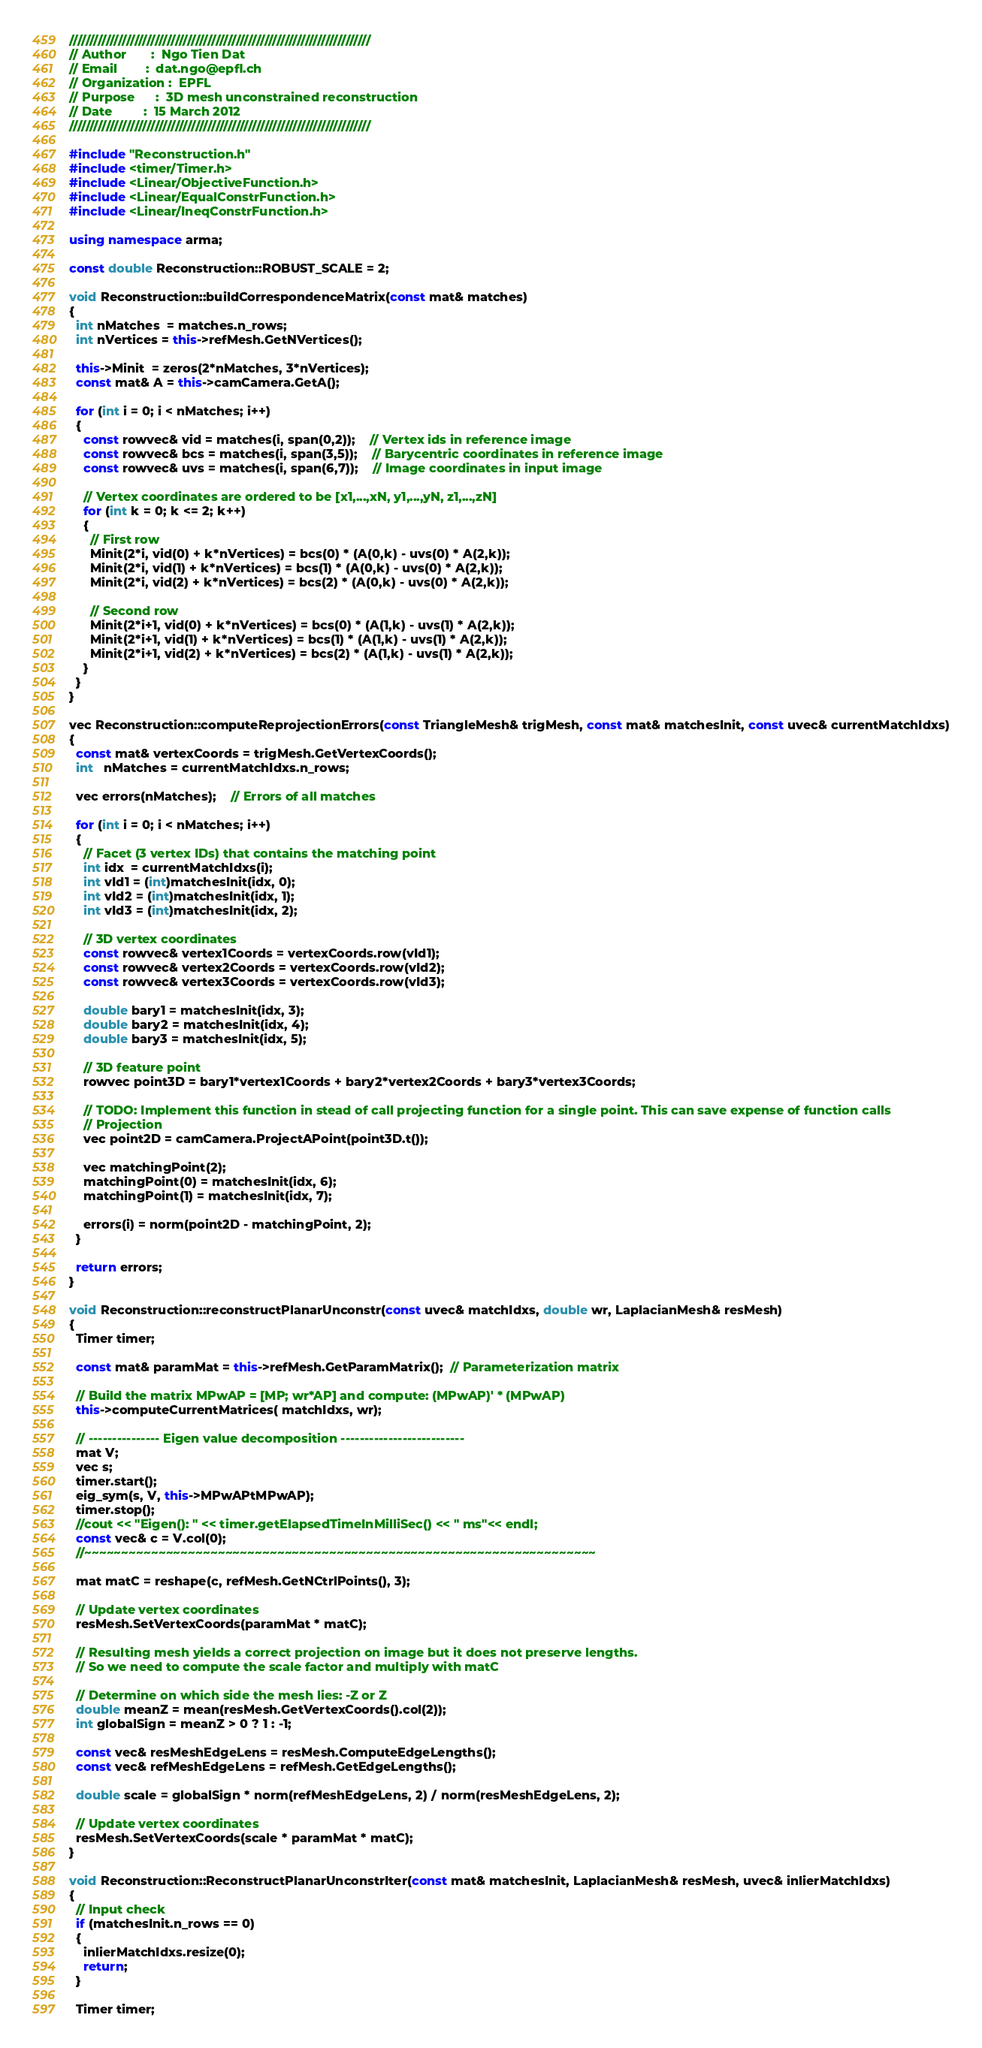<code> <loc_0><loc_0><loc_500><loc_500><_C++_>//////////////////////////////////////////////////////////////////////////
// Author       :  Ngo Tien Dat
// Email        :  dat.ngo@epfl.ch
// Organization :  EPFL
// Purpose      :  3D mesh unconstrained reconstruction
// Date         :  15 March 2012
//////////////////////////////////////////////////////////////////////////

#include "Reconstruction.h"
#include <timer/Timer.h>
#include <Linear/ObjectiveFunction.h>
#include <Linear/EqualConstrFunction.h>
#include <Linear/IneqConstrFunction.h>

using namespace arma;

const double Reconstruction::ROBUST_SCALE = 2;

void Reconstruction::buildCorrespondenceMatrix(const mat& matches)
{
  int nMatches  = matches.n_rows;
  int nVertices = this->refMesh.GetNVertices();

  this->Minit  = zeros(2*nMatches, 3*nVertices);
  const mat& A = this->camCamera.GetA();

  for (int i = 0; i < nMatches; i++)
  {
    const rowvec& vid = matches(i, span(0,2));    // Vertex ids in reference image
    const rowvec& bcs = matches(i, span(3,5));    // Barycentric coordinates in reference image
    const rowvec& uvs = matches(i, span(6,7));    // Image coordinates in input image

    // Vertex coordinates are ordered to be [x1,...,xN, y1,...,yN, z1,...,zN]
    for (int k = 0; k <= 2; k++)
    {
      // First row
      Minit(2*i, vid(0) + k*nVertices) = bcs(0) * (A(0,k) - uvs(0) * A(2,k));
      Minit(2*i, vid(1) + k*nVertices) = bcs(1) * (A(0,k) - uvs(0) * A(2,k));
      Minit(2*i, vid(2) + k*nVertices) = bcs(2) * (A(0,k) - uvs(0) * A(2,k));

      // Second row
      Minit(2*i+1, vid(0) + k*nVertices) = bcs(0) * (A(1,k) - uvs(1) * A(2,k));
      Minit(2*i+1, vid(1) + k*nVertices) = bcs(1) * (A(1,k) - uvs(1) * A(2,k));
      Minit(2*i+1, vid(2) + k*nVertices) = bcs(2) * (A(1,k) - uvs(1) * A(2,k));      
    }
  }
}

vec Reconstruction::computeReprojectionErrors(const TriangleMesh& trigMesh, const mat& matchesInit, const uvec& currentMatchIdxs)
{
  const mat& vertexCoords = trigMesh.GetVertexCoords();
  int   nMatches = currentMatchIdxs.n_rows;

  vec errors(nMatches);    // Errors of all matches

  for (int i = 0; i < nMatches; i++)
  {
    // Facet (3 vertex IDs) that contains the matching point
    int idx  = currentMatchIdxs(i);
    int vId1 = (int)matchesInit(idx, 0);
    int vId2 = (int)matchesInit(idx, 1);
    int vId3 = (int)matchesInit(idx, 2);

    // 3D vertex coordinates
    const rowvec& vertex1Coords = vertexCoords.row(vId1);
    const rowvec& vertex2Coords = vertexCoords.row(vId2);
    const rowvec& vertex3Coords = vertexCoords.row(vId3);

    double bary1 = matchesInit(idx, 3);
    double bary2 = matchesInit(idx, 4);
    double bary3 = matchesInit(idx, 5);

    // 3D feature point
    rowvec point3D = bary1*vertex1Coords + bary2*vertex2Coords + bary3*vertex3Coords;
    
    // TODO: Implement this function in stead of call projecting function for a single point. This can save expense of function calls
    // Projection
    vec point2D = camCamera.ProjectAPoint(point3D.t());
      
    vec matchingPoint(2);
    matchingPoint(0) = matchesInit(idx, 6);
    matchingPoint(1) = matchesInit(idx, 7);

    errors(i) = norm(point2D - matchingPoint, 2);
  }

  return errors;
}

void Reconstruction::reconstructPlanarUnconstr(const uvec& matchIdxs, double wr, LaplacianMesh& resMesh)
{
  Timer timer;
  
  const mat& paramMat = this->refMesh.GetParamMatrix();  // Parameterization matrix    
  
  // Build the matrix MPwAP = [MP; wr*AP] and compute: (MPwAP)' * (MPwAP)
  this->computeCurrentMatrices( matchIdxs, wr);

  // --------------- Eigen value decomposition --------------------------
  mat V;
  vec s;
  timer.start();
  eig_sym(s, V, this->MPwAPtMPwAP);
  timer.stop();
  //cout << "Eigen(): " << timer.getElapsedTimeInMilliSec() << " ms"<< endl;
  const vec& c = V.col(0);
  //~~~~~~~~~~~~~~~~~~~~~~~~~~~~~~~~~~~~~~~~~~~~~~~~~~~~~~~~~~~~~~~~~~~~~

  mat matC = reshape(c, refMesh.GetNCtrlPoints(), 3);

  // Update vertex coordinates
  resMesh.SetVertexCoords(paramMat * matC);
  
  // Resulting mesh yields a correct projection on image but it does not preserve lengths. 
  // So we need to compute the scale factor and multiply with matC

  // Determine on which side the mesh lies: -Z or Z
  double meanZ = mean(resMesh.GetVertexCoords().col(2));
  int globalSign = meanZ > 0 ? 1 : -1;

  const vec& resMeshEdgeLens = resMesh.ComputeEdgeLengths();
  const vec& refMeshEdgeLens = refMesh.GetEdgeLengths();

  double scale = globalSign * norm(refMeshEdgeLens, 2) / norm(resMeshEdgeLens, 2);

  // Update vertex coordinates
  resMesh.SetVertexCoords(scale * paramMat * matC);
}

void Reconstruction::ReconstructPlanarUnconstrIter(const mat& matchesInit, LaplacianMesh& resMesh, uvec& inlierMatchIdxs)
{
  // Input check
  if (matchesInit.n_rows == 0) 
  {
    inlierMatchIdxs.resize(0);
    return;
  }

  Timer timer;
</code> 